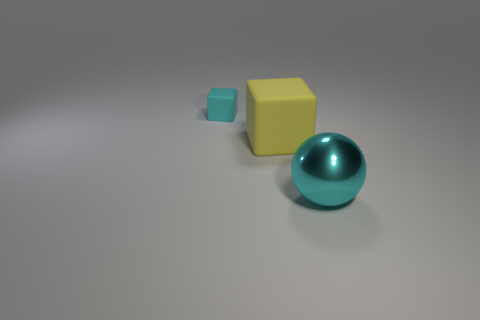What colors are featured in the image? The image displays a ball that is teal-colored, and two cubes, one larger and yellow, and a smaller one in a lighter shade of teal, all set against a neutral grey background. 